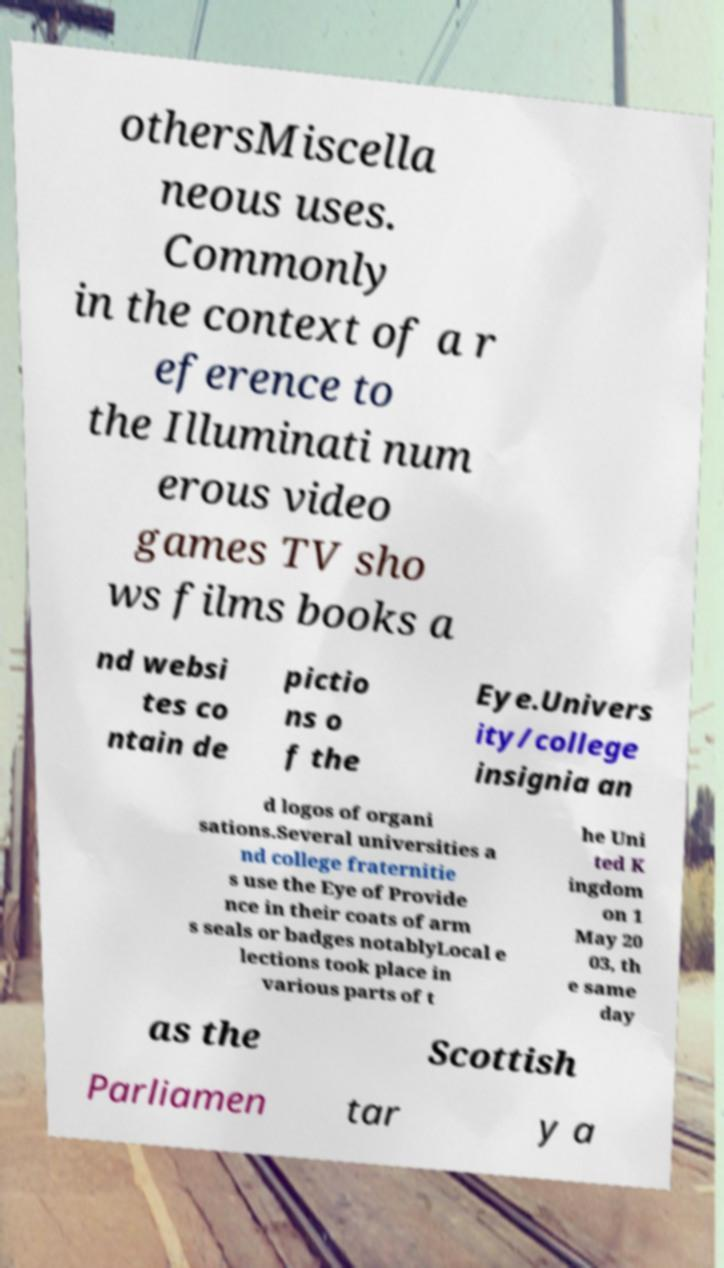Can you accurately transcribe the text from the provided image for me? othersMiscella neous uses. Commonly in the context of a r eference to the Illuminati num erous video games TV sho ws films books a nd websi tes co ntain de pictio ns o f the Eye.Univers ity/college insignia an d logos of organi sations.Several universities a nd college fraternitie s use the Eye of Provide nce in their coats of arm s seals or badges notablyLocal e lections took place in various parts of t he Uni ted K ingdom on 1 May 20 03, th e same day as the Scottish Parliamen tar y a 